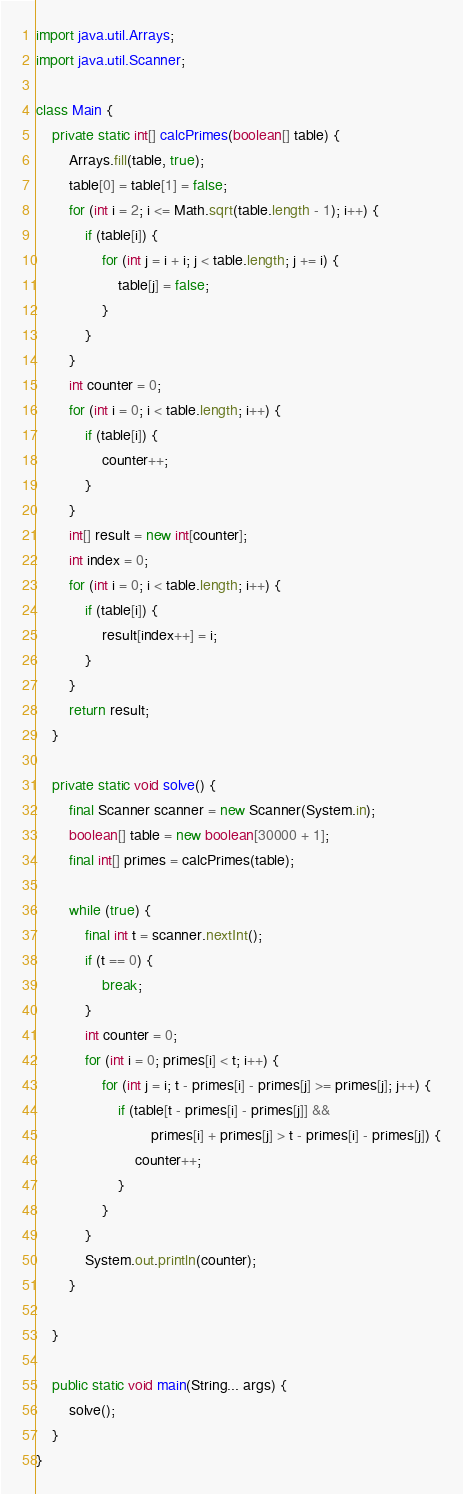<code> <loc_0><loc_0><loc_500><loc_500><_Java_>import java.util.Arrays;
import java.util.Scanner;

class Main {
    private static int[] calcPrimes(boolean[] table) {
        Arrays.fill(table, true);
        table[0] = table[1] = false;
        for (int i = 2; i <= Math.sqrt(table.length - 1); i++) {
            if (table[i]) {
                for (int j = i + i; j < table.length; j += i) {
                    table[j] = false;
                }
            }
        }
        int counter = 0;
        for (int i = 0; i < table.length; i++) {
            if (table[i]) {
                counter++;
            }
        }
        int[] result = new int[counter];
        int index = 0;
        for (int i = 0; i < table.length; i++) {
            if (table[i]) {
                result[index++] = i;
            }
        }
        return result;
    }

    private static void solve() {
        final Scanner scanner = new Scanner(System.in);
        boolean[] table = new boolean[30000 + 1];
        final int[] primes = calcPrimes(table);
        
        while (true) {
            final int t = scanner.nextInt();
            if (t == 0) {
                break;
            }
            int counter = 0;
            for (int i = 0; primes[i] < t; i++) {
                for (int j = i; t - primes[i] - primes[j] >= primes[j]; j++) {
                    if (table[t - primes[i] - primes[j]] &&
                            primes[i] + primes[j] > t - primes[i] - primes[j]) {
                        counter++;
                    }
                }
            }
            System.out.println(counter);
        }

    }

    public static void main(String... args) {
        solve();
    }
}</code> 